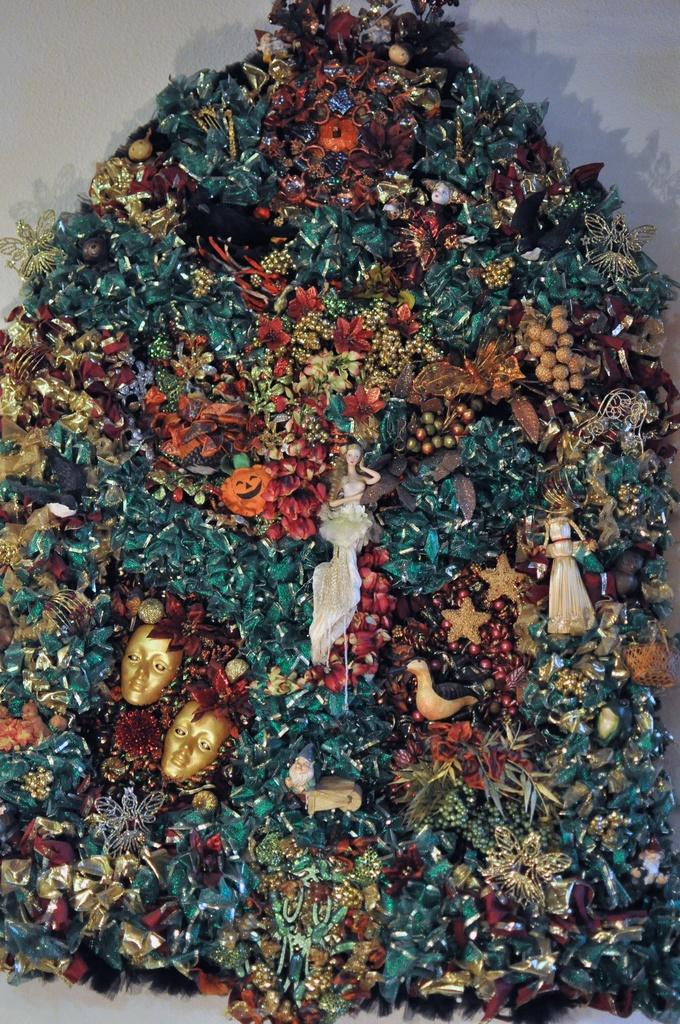What types of objects are present in the image? The image contains decorative items. What type of apparatus is being used by the women in the image? There are no women or apparatus present in the image; it only contains decorative items. 